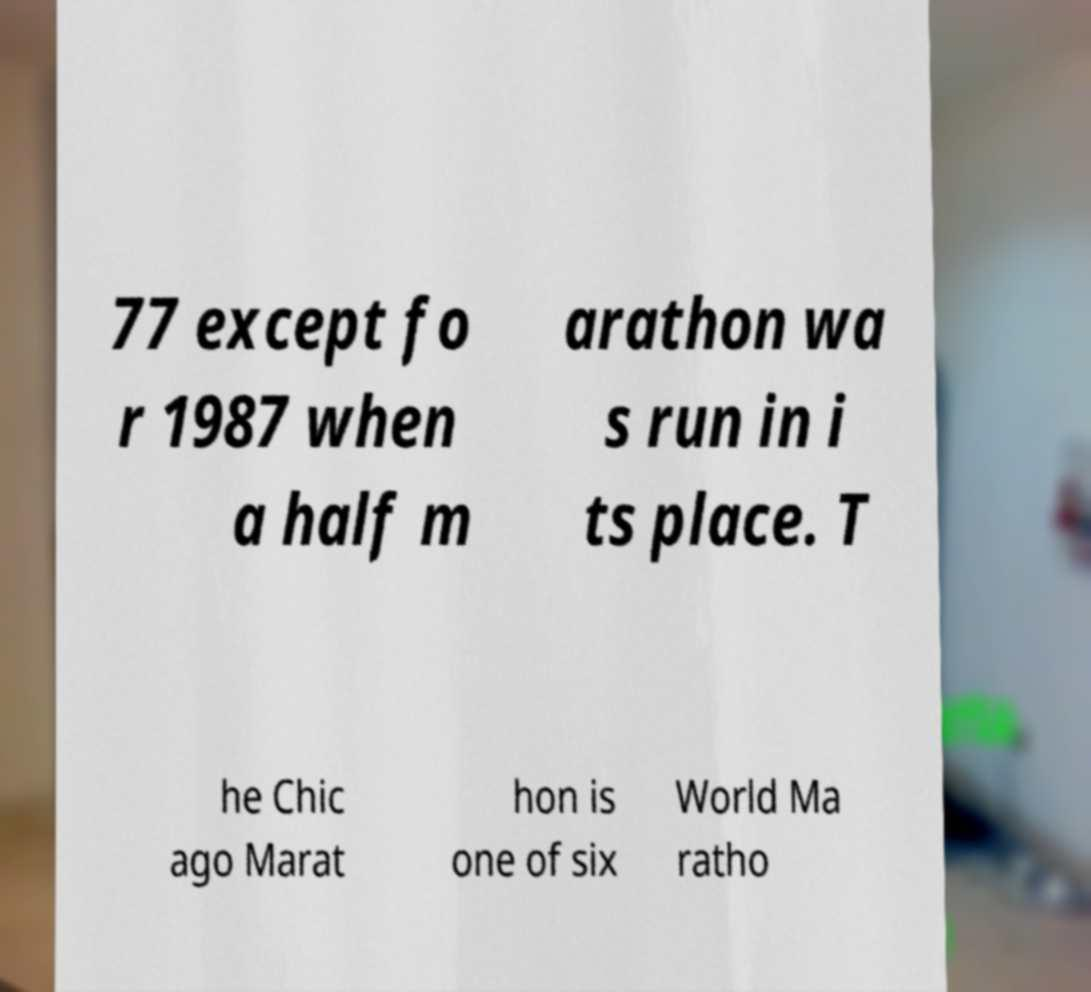Please read and relay the text visible in this image. What does it say? 77 except fo r 1987 when a half m arathon wa s run in i ts place. T he Chic ago Marat hon is one of six World Ma ratho 